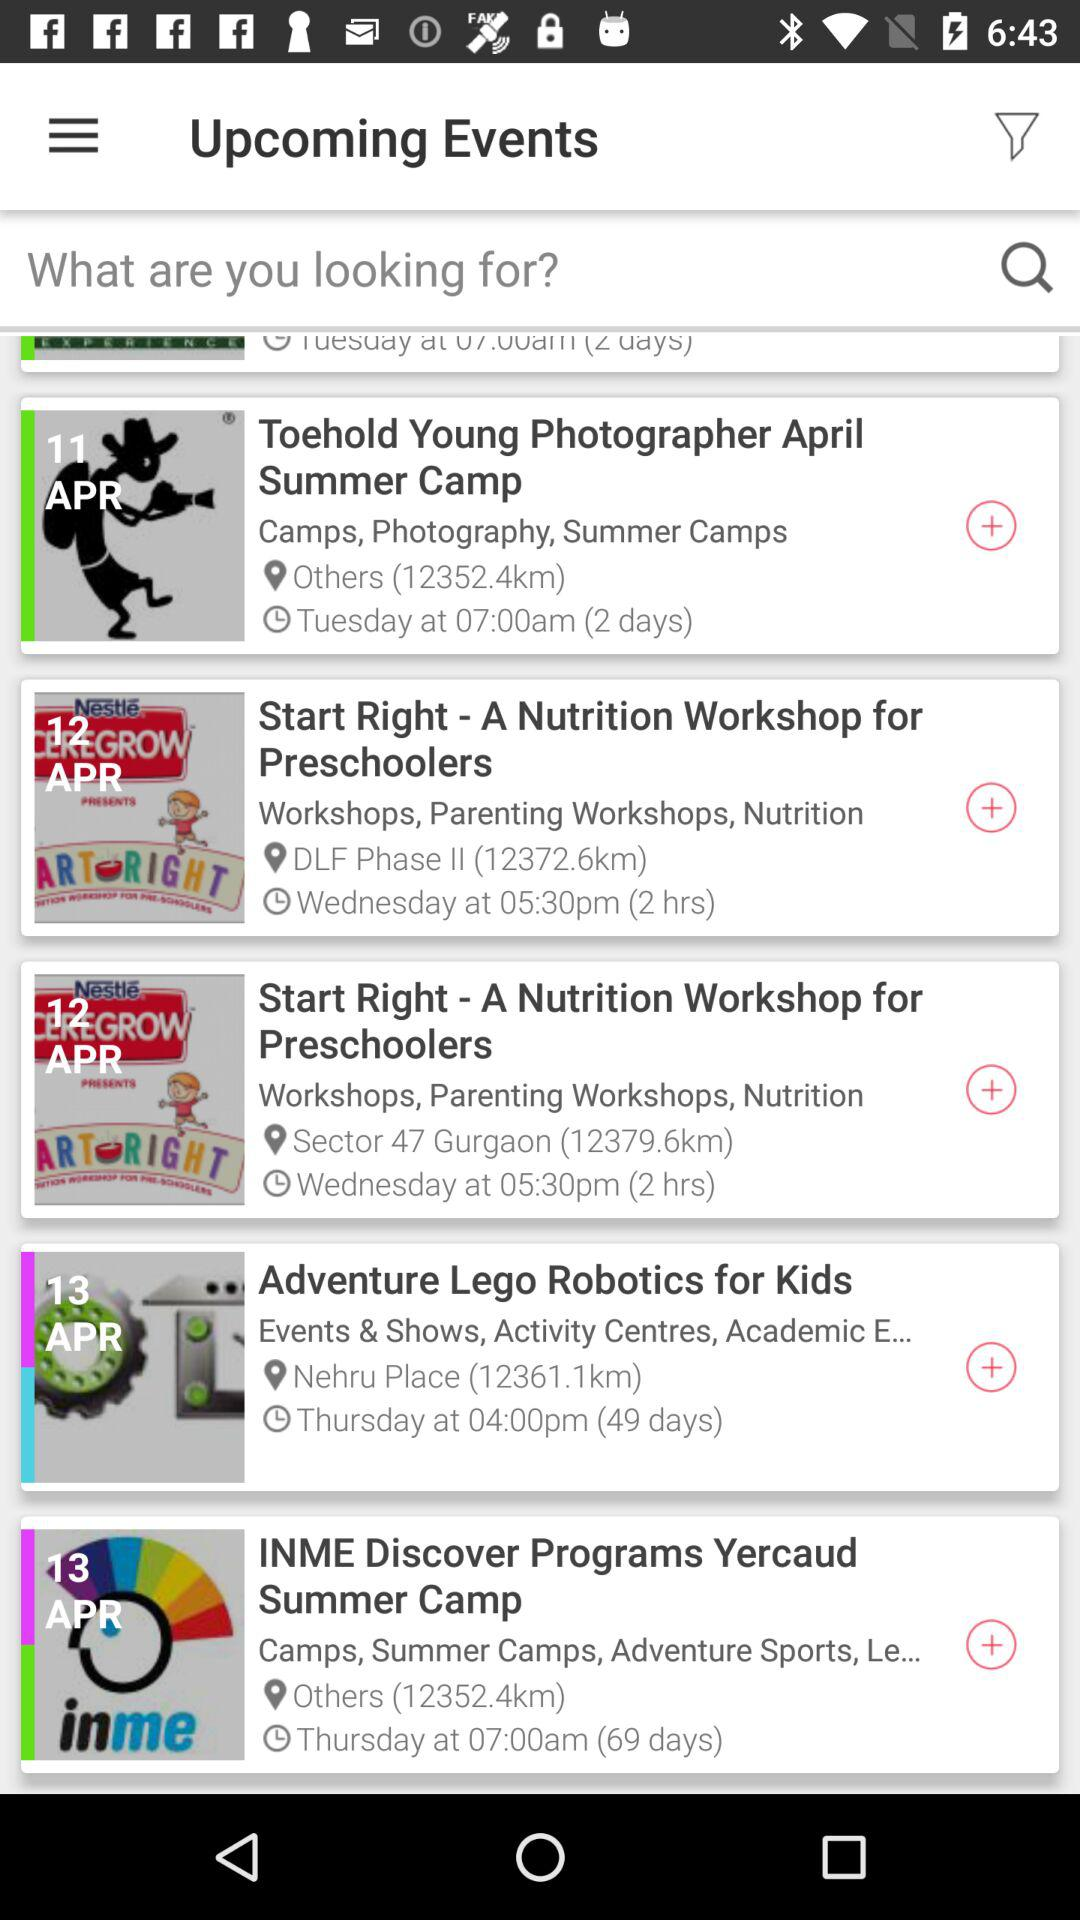Name the event which is held at Nehru Place? The name of the event is "Adventure Lego Robotics for Kids". 